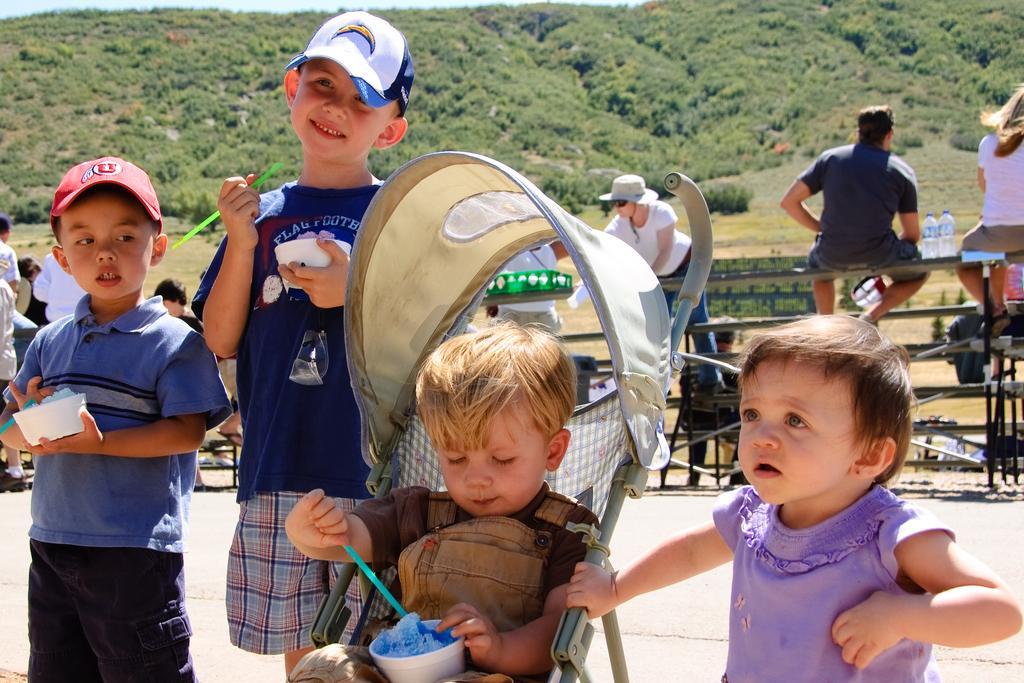Could you give a brief overview of what you see in this image? In front of the picture, we see a boy is sitting in the stroller and he is holding a straw and a cup. Beside him, we see a girl is standing. On the left side, we see two boys are standing and they are holding the straws and cups in their hands. Behind them, we see the railing and the people are standing. We see a man is sitting on the chair. On the left side, we see the people are standing. On the right side, we see a man and the women are sitting. Beside them, we see the water bottles. There are trees and a hill in the background. At the bottom, we see the road. 